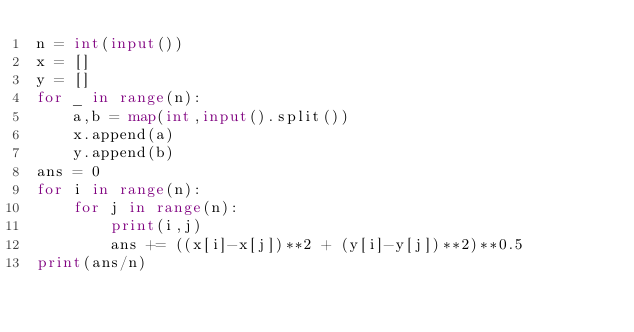Convert code to text. <code><loc_0><loc_0><loc_500><loc_500><_Python_>n = int(input())
x = []
y = []
for _ in range(n):
    a,b = map(int,input().split())
    x.append(a)
    y.append(b)
ans = 0
for i in range(n):
    for j in range(n):
        print(i,j)
        ans += ((x[i]-x[j])**2 + (y[i]-y[j])**2)**0.5
print(ans/n)</code> 